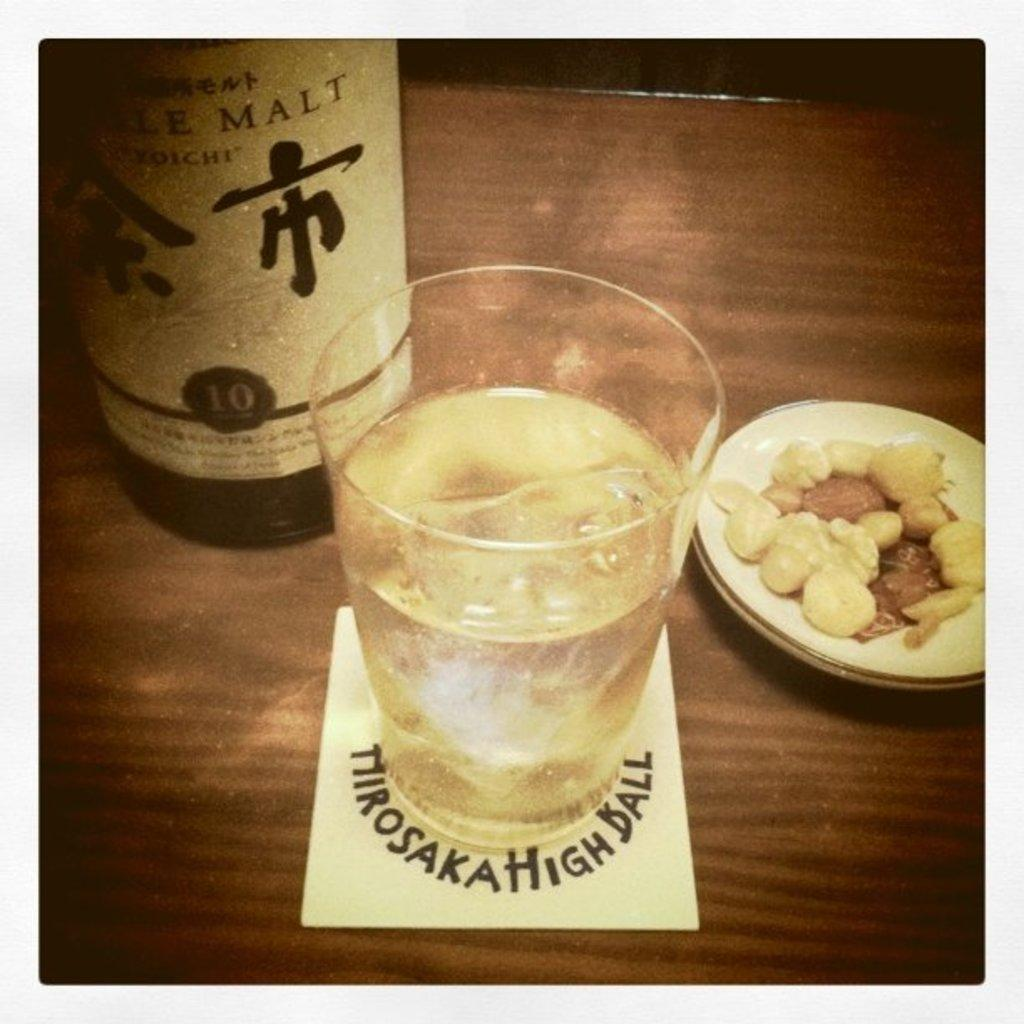<image>
Describe the image concisely. A bottle of malt liquor sits on a wooden surface next to a full glass. 